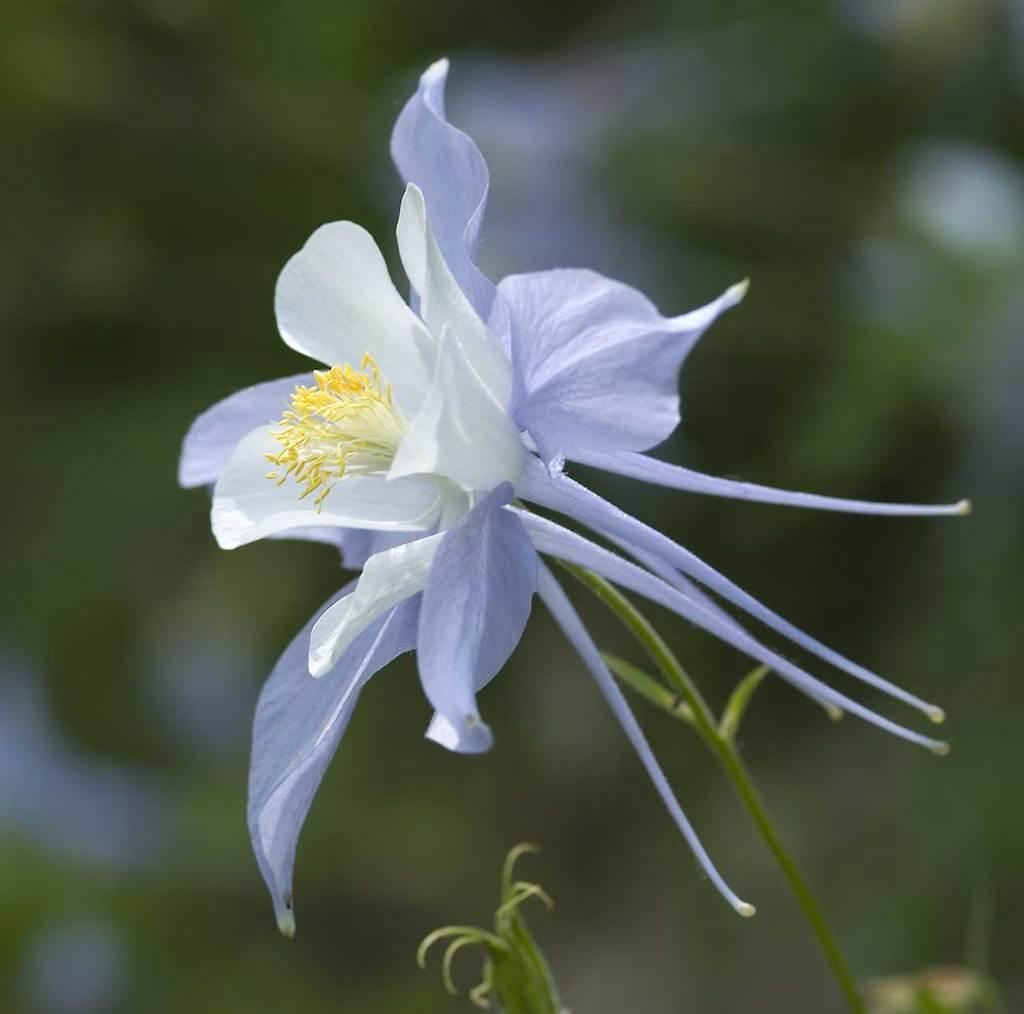What is the main subject of the image? There is a flower on a stem in the image. Can you describe the flower in more detail? The flower has a bud at the bottom. What can be observed about the background of the image? The background of the image is blurred. What type of net is being used for educational purposes in the image? There is no net or educational activity present in the image; it features a flower on a stem with a blurred background. 